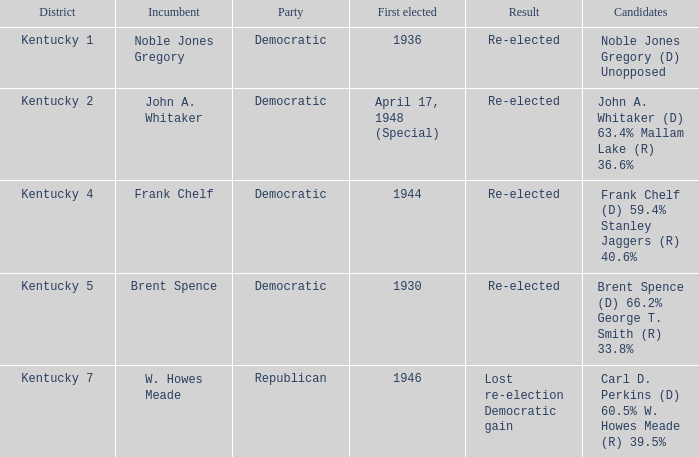Which party won in the election in voting district Kentucky 5? Democratic. 